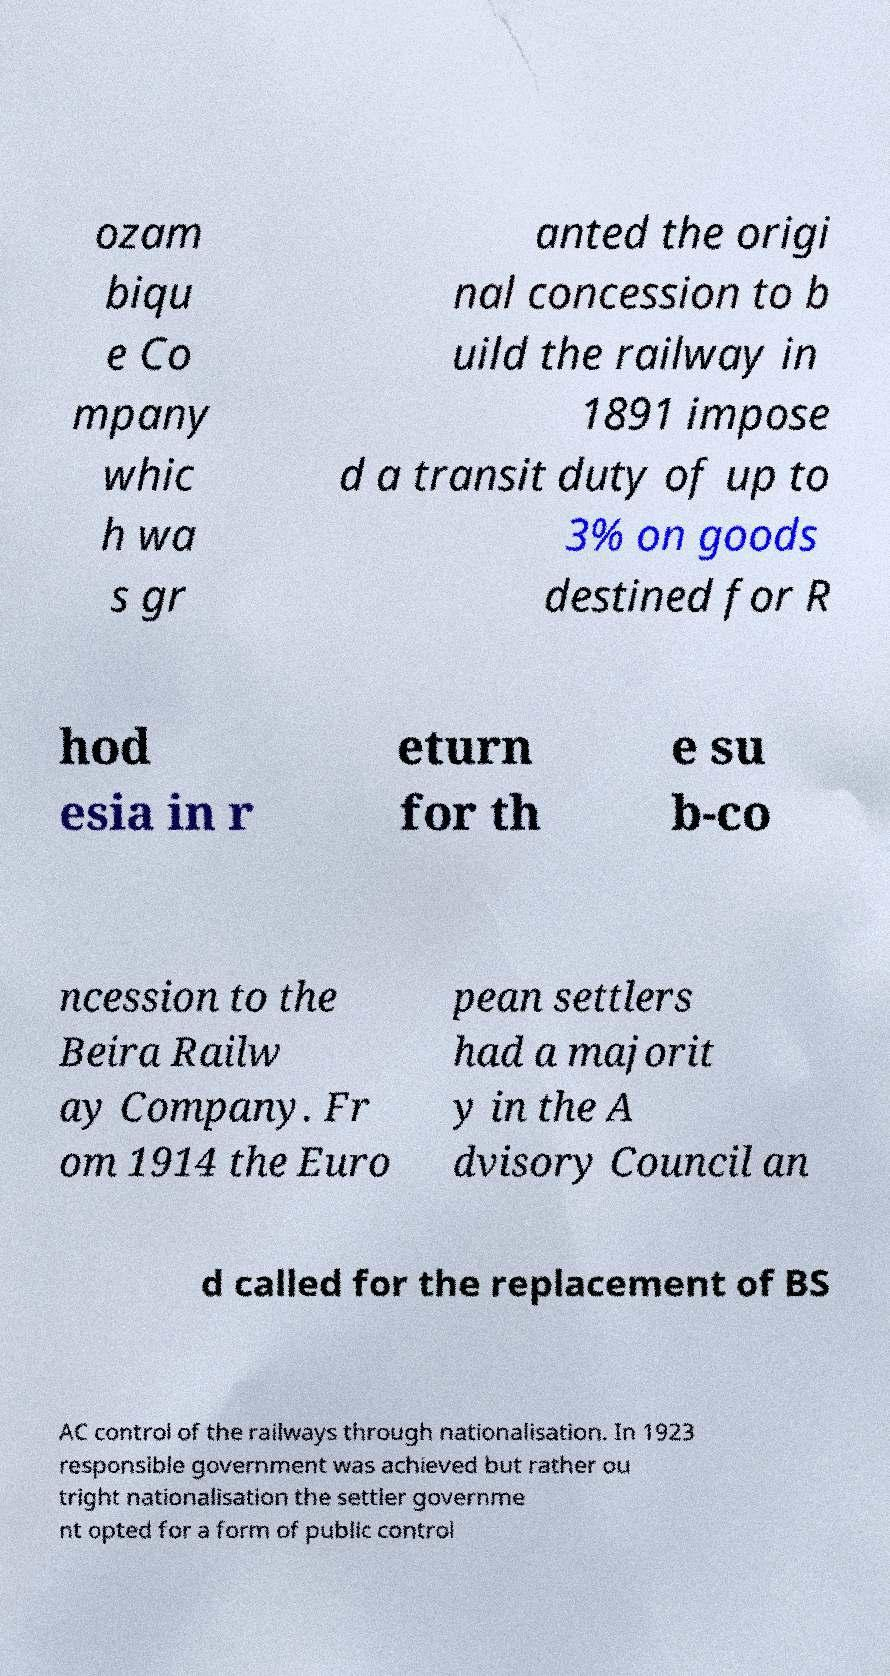Please identify and transcribe the text found in this image. ozam biqu e Co mpany whic h wa s gr anted the origi nal concession to b uild the railway in 1891 impose d a transit duty of up to 3% on goods destined for R hod esia in r eturn for th e su b-co ncession to the Beira Railw ay Company. Fr om 1914 the Euro pean settlers had a majorit y in the A dvisory Council an d called for the replacement of BS AC control of the railways through nationalisation. In 1923 responsible government was achieved but rather ou tright nationalisation the settler governme nt opted for a form of public control 